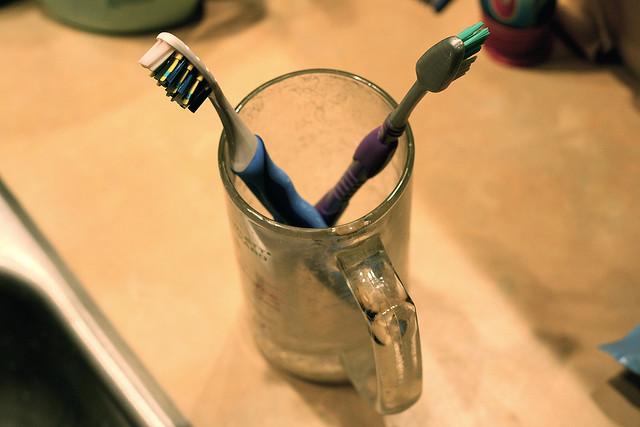Where are the toothbrushes?
Concise answer only. In glass. Are both toothbrushes the same color?
Answer briefly. No. Does the cup look dirty?
Answer briefly. Yes. What figure is on the glass?
Quick response, please. Toothbrush. 